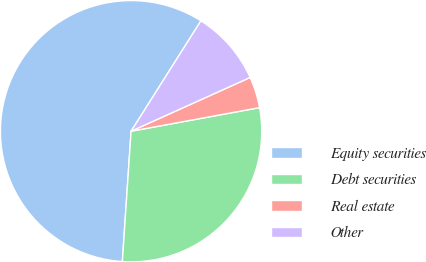Convert chart to OTSL. <chart><loc_0><loc_0><loc_500><loc_500><pie_chart><fcel>Equity securities<fcel>Debt securities<fcel>Real estate<fcel>Other<nl><fcel>57.92%<fcel>28.96%<fcel>3.86%<fcel>9.27%<nl></chart> 